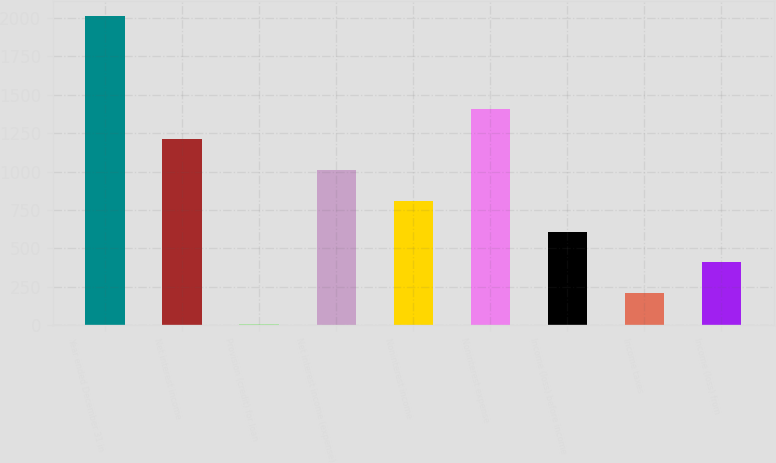Convert chart. <chart><loc_0><loc_0><loc_500><loc_500><bar_chart><fcel>Year ended December 31 in<fcel>Net interest income<fcel>Provision (credit) for loan<fcel>Net interest income (expense)<fcel>Noninterest income<fcel>Noninterest expense<fcel>Income (loss) before income<fcel>Income taxes<fcel>Income (loss) from<nl><fcel>2012<fcel>1210.8<fcel>9<fcel>1010.5<fcel>810.2<fcel>1411.1<fcel>609.9<fcel>209.3<fcel>409.6<nl></chart> 